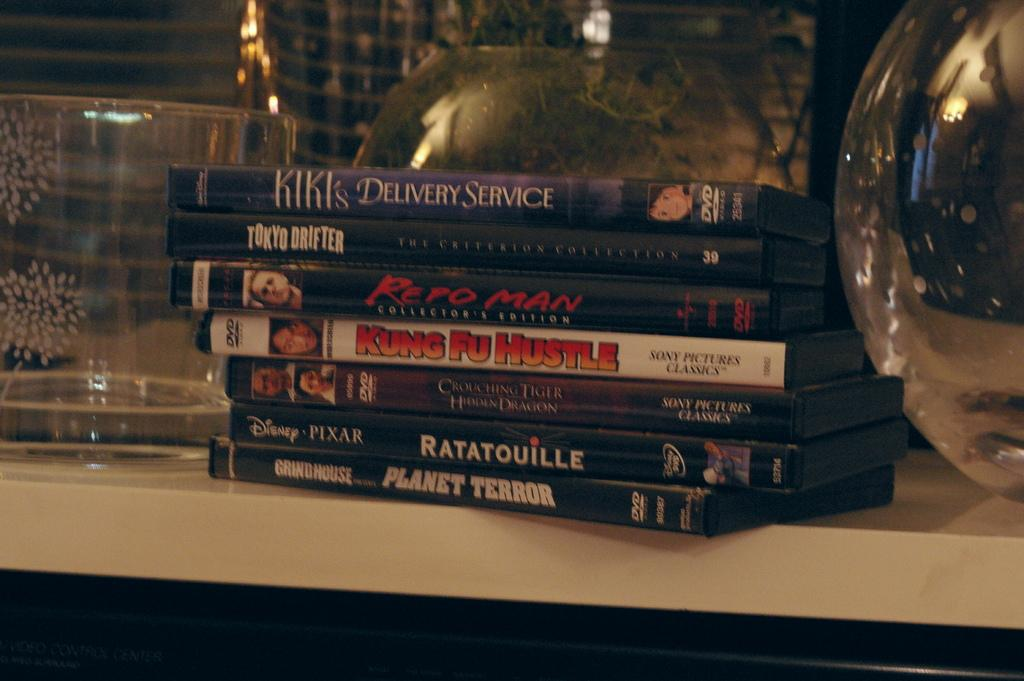Provide a one-sentence caption for the provided image. Kiki's Delivery Service DVD on top of other DVDs. 